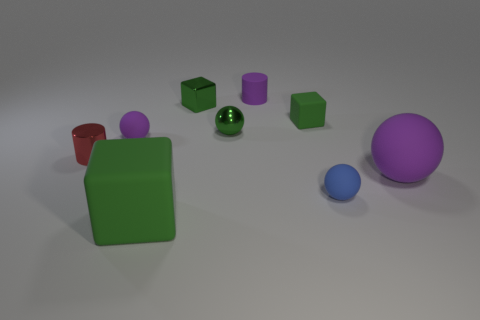What is the shape of the purple thing that is behind the small rubber sphere that is left of the matte cube that is in front of the large purple sphere?
Provide a short and direct response. Cylinder. Is the number of small green cubes that are in front of the small matte cylinder greater than the number of tiny red rubber cylinders?
Your answer should be compact. Yes. There is a large purple rubber thing; is its shape the same as the small matte thing in front of the small metallic cylinder?
Make the answer very short. Yes. What shape is the metal object that is the same color as the small metallic cube?
Offer a very short reply. Sphere. How many cubes are behind the large ball that is behind the large matte object on the left side of the matte cylinder?
Your response must be concise. 2. There is a shiny cylinder that is the same size as the green ball; what color is it?
Ensure brevity in your answer.  Red. How big is the rubber cylinder that is behind the rubber sphere that is left of the large block?
Your response must be concise. Small. What size is the other rubber block that is the same color as the small rubber cube?
Make the answer very short. Large. How many other objects are the same size as the green metal cube?
Provide a succinct answer. 6. How many tiny blue metallic cylinders are there?
Your response must be concise. 0. 